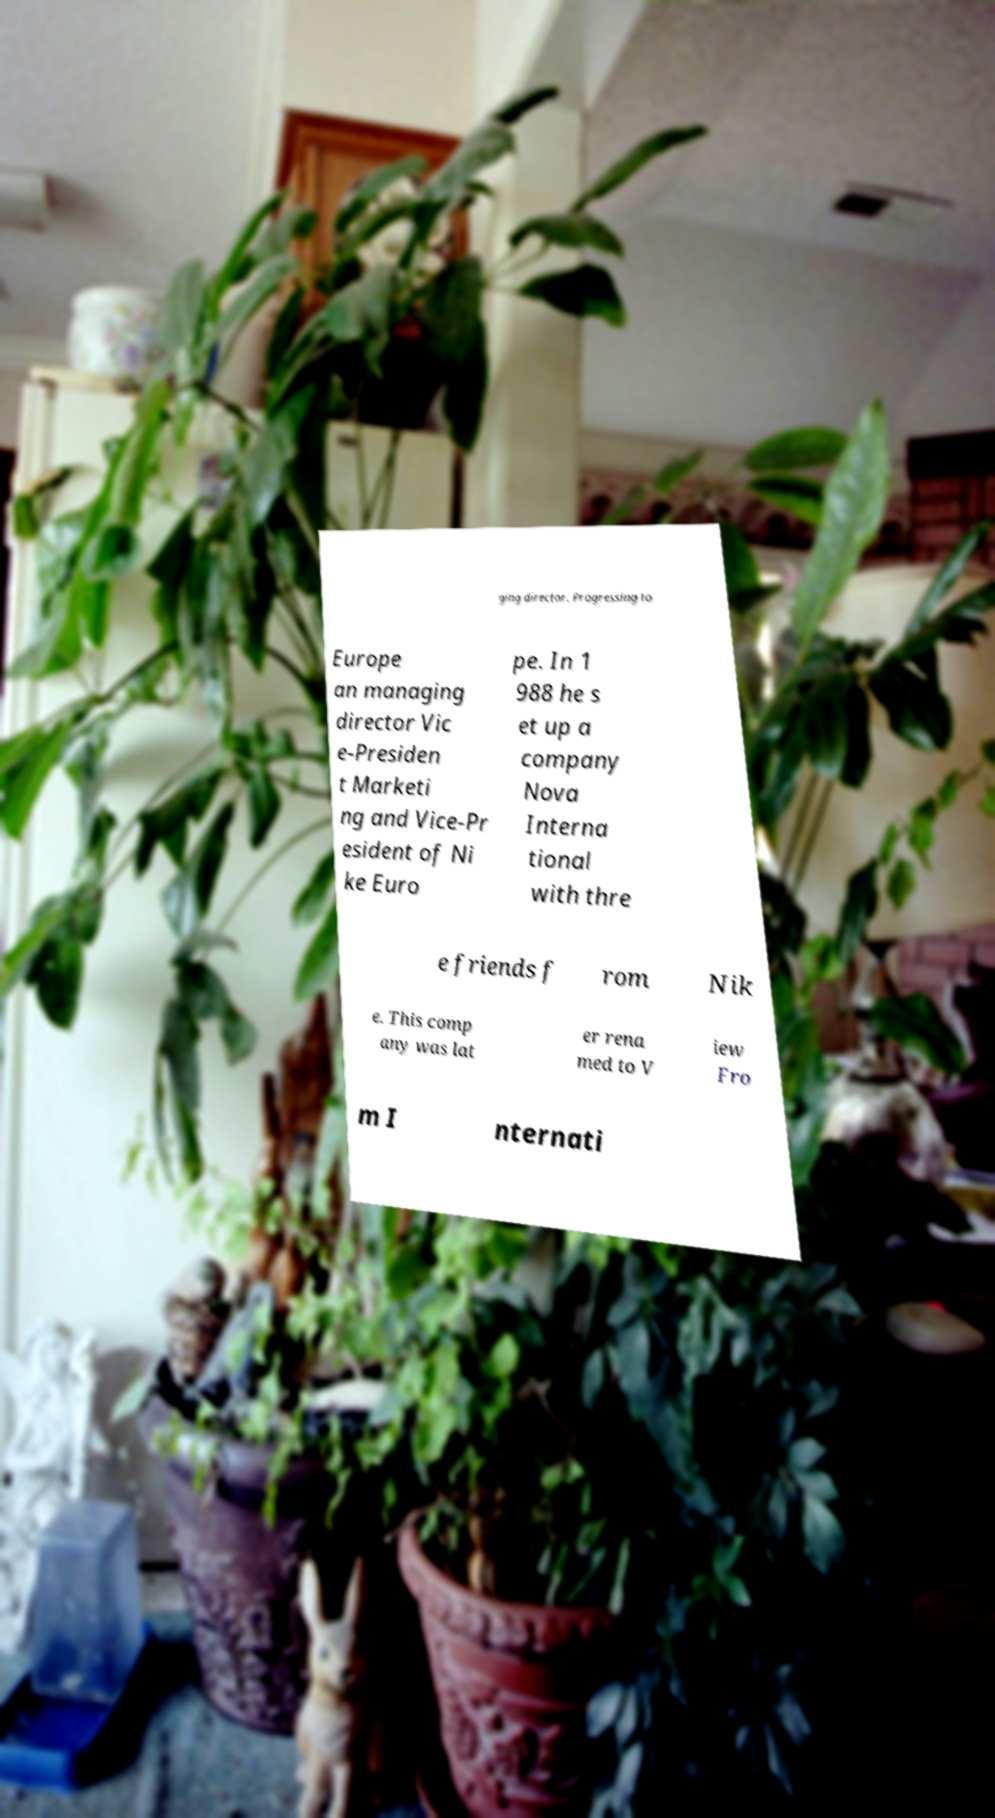There's text embedded in this image that I need extracted. Can you transcribe it verbatim? ging director. Progressing to Europe an managing director Vic e-Presiden t Marketi ng and Vice-Pr esident of Ni ke Euro pe. In 1 988 he s et up a company Nova Interna tional with thre e friends f rom Nik e. This comp any was lat er rena med to V iew Fro m I nternati 